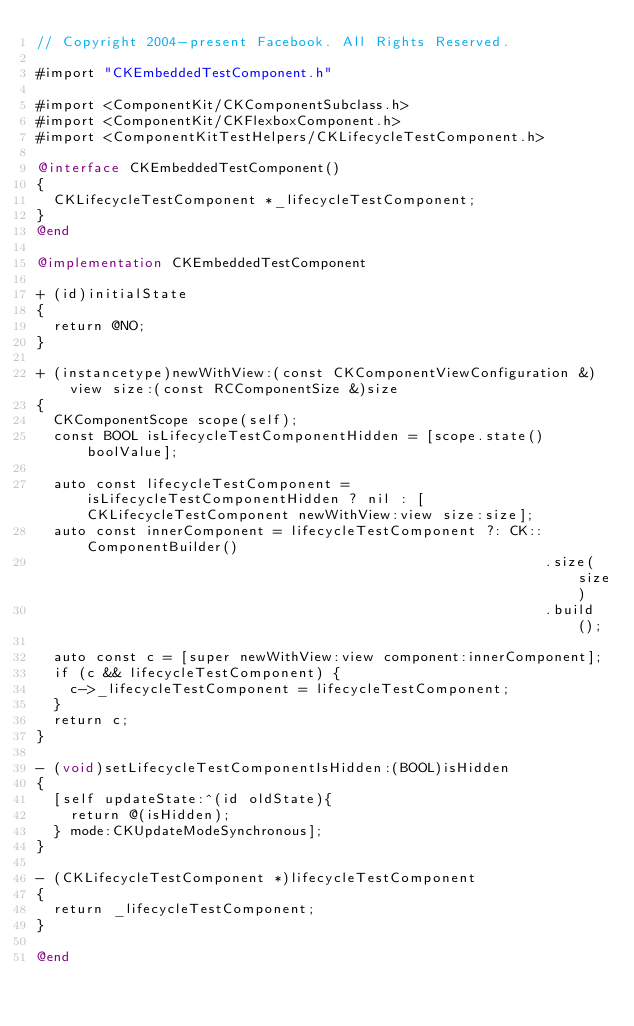Convert code to text. <code><loc_0><loc_0><loc_500><loc_500><_ObjectiveC_>// Copyright 2004-present Facebook. All Rights Reserved.

#import "CKEmbeddedTestComponent.h"

#import <ComponentKit/CKComponentSubclass.h>
#import <ComponentKit/CKFlexboxComponent.h>
#import <ComponentKitTestHelpers/CKLifecycleTestComponent.h>

@interface CKEmbeddedTestComponent()
{
  CKLifecycleTestComponent *_lifecycleTestComponent;
}
@end

@implementation CKEmbeddedTestComponent

+ (id)initialState
{
  return @NO;
}

+ (instancetype)newWithView:(const CKComponentViewConfiguration &)view size:(const RCComponentSize &)size
{
  CKComponentScope scope(self);
  const BOOL isLifecycleTestComponentHidden = [scope.state() boolValue];
  
  auto const lifecycleTestComponent = isLifecycleTestComponentHidden ? nil : [CKLifecycleTestComponent newWithView:view size:size];
  auto const innerComponent = lifecycleTestComponent ?: CK::ComponentBuilder()
                                                            .size(size)
                                                            .build();
  
  auto const c = [super newWithView:view component:innerComponent];
  if (c && lifecycleTestComponent) {
    c->_lifecycleTestComponent = lifecycleTestComponent;
  }
  return c;
}

- (void)setLifecycleTestComponentIsHidden:(BOOL)isHidden
{
  [self updateState:^(id oldState){
    return @(isHidden);
  } mode:CKUpdateModeSynchronous];
}

- (CKLifecycleTestComponent *)lifecycleTestComponent
{
  return _lifecycleTestComponent;
}

@end
</code> 